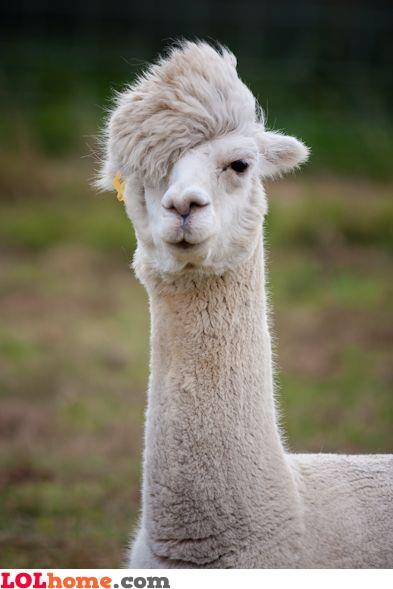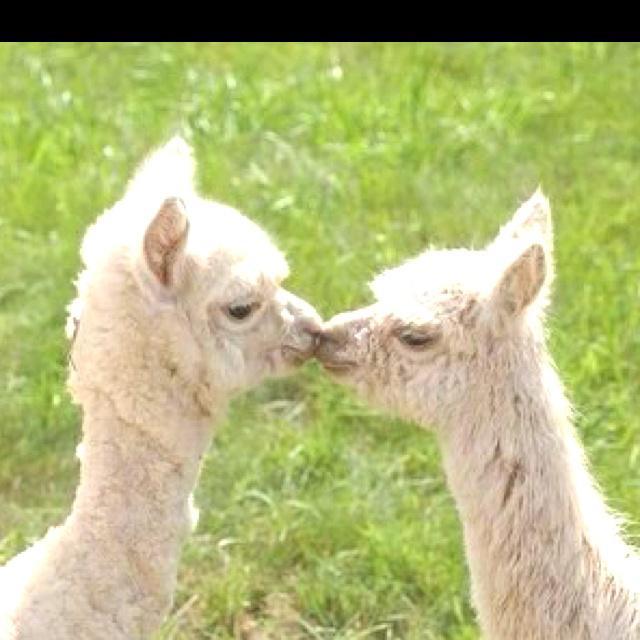The first image is the image on the left, the second image is the image on the right. For the images shown, is this caption "The left and right image contains the same number of alpacas." true? Answer yes or no. No. The first image is the image on the left, the second image is the image on the right. Evaluate the accuracy of this statement regarding the images: "Two white llamas of similar size are in a kissing pose in the right image.". Is it true? Answer yes or no. Yes. 